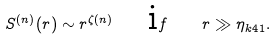Convert formula to latex. <formula><loc_0><loc_0><loc_500><loc_500>S ^ { ( n ) } ( r ) \sim r ^ { \zeta ( n ) } \quad { \mbox i f } \quad r \gg \eta _ { k 4 1 } .</formula> 